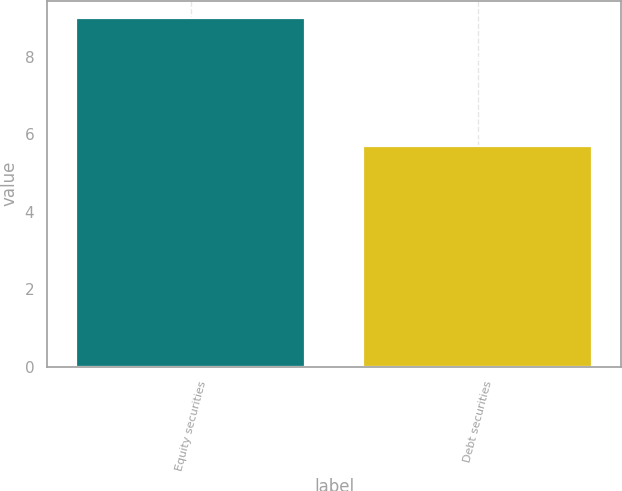<chart> <loc_0><loc_0><loc_500><loc_500><bar_chart><fcel>Equity securities<fcel>Debt securities<nl><fcel>9<fcel>5.7<nl></chart> 